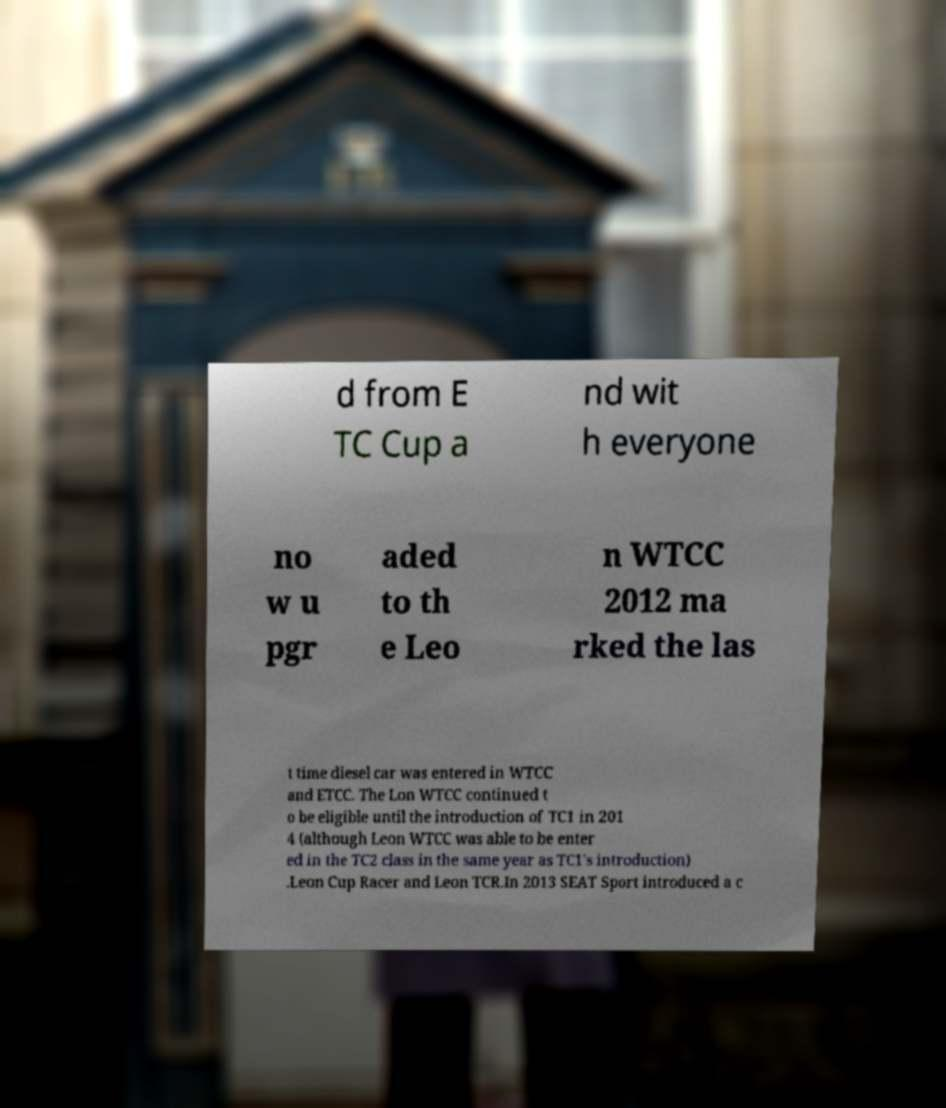Please read and relay the text visible in this image. What does it say? d from E TC Cup a nd wit h everyone no w u pgr aded to th e Leo n WTCC 2012 ma rked the las t time diesel car was entered in WTCC and ETCC. The Lon WTCC continued t o be eligible until the introduction of TC1 in 201 4 (although Leon WTCC was able to be enter ed in the TC2 class in the same year as TC1's introduction) .Leon Cup Racer and Leon TCR.In 2013 SEAT Sport introduced a c 